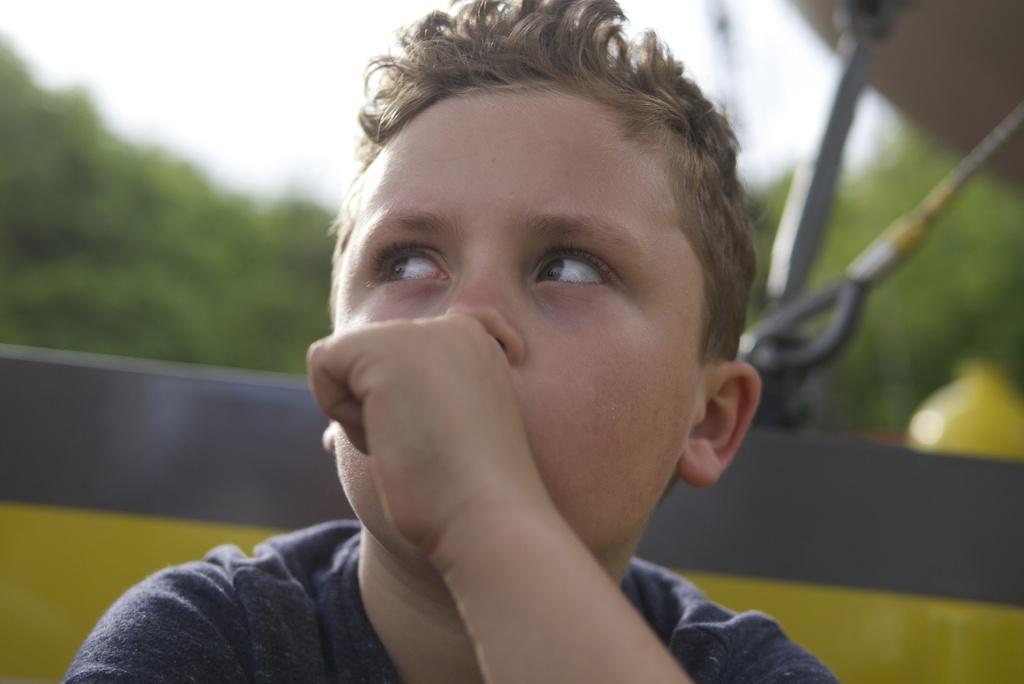Who is the main subject in the image? There is a boy in the image. What is located behind the boy? There is an object behind the boy. What type of natural environment is visible in the background of the image? There are trees in the background of the image. What is visible in the sky in the background of the image? The sky is visible in the background of the image. What type of comb is the cat using to groom itself in the image? There is no cat or comb present in the image. How is the ice being used in the image? There is no ice present in the image. 